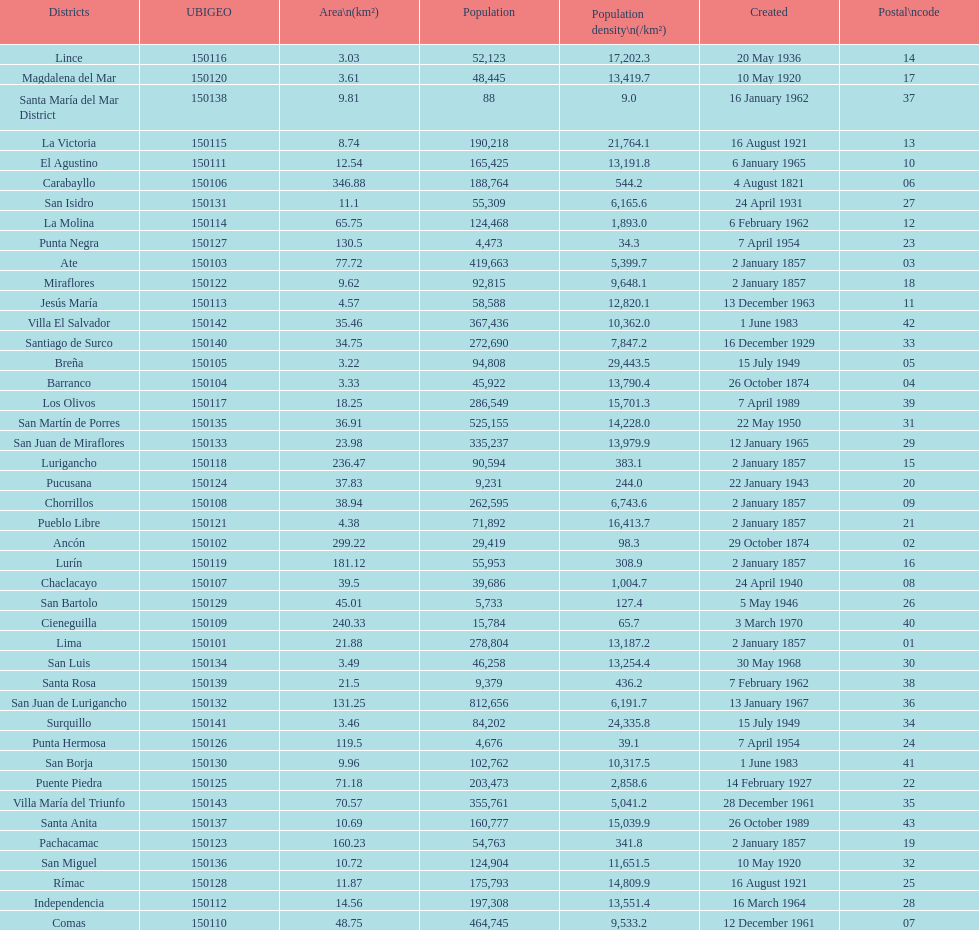What was the last district created? Santa Anita. 